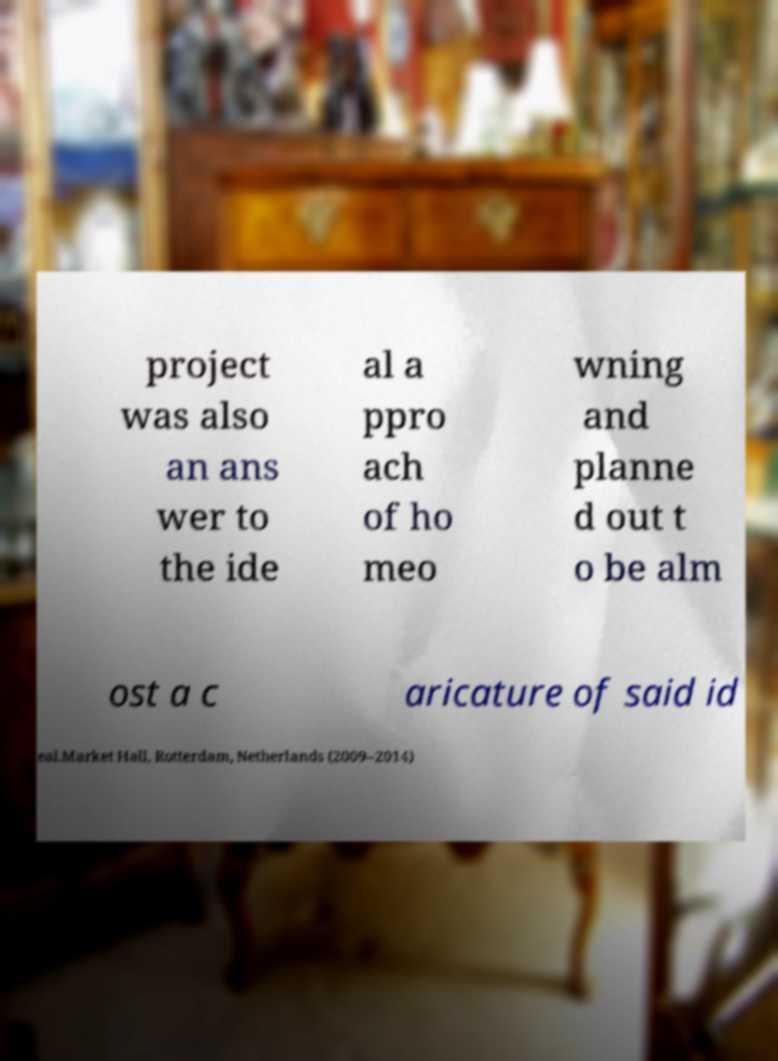For documentation purposes, I need the text within this image transcribed. Could you provide that? project was also an ans wer to the ide al a ppro ach of ho meo wning and planne d out t o be alm ost a c aricature of said id eal.Market Hall, Rotterdam, Netherlands (2009–2014) 